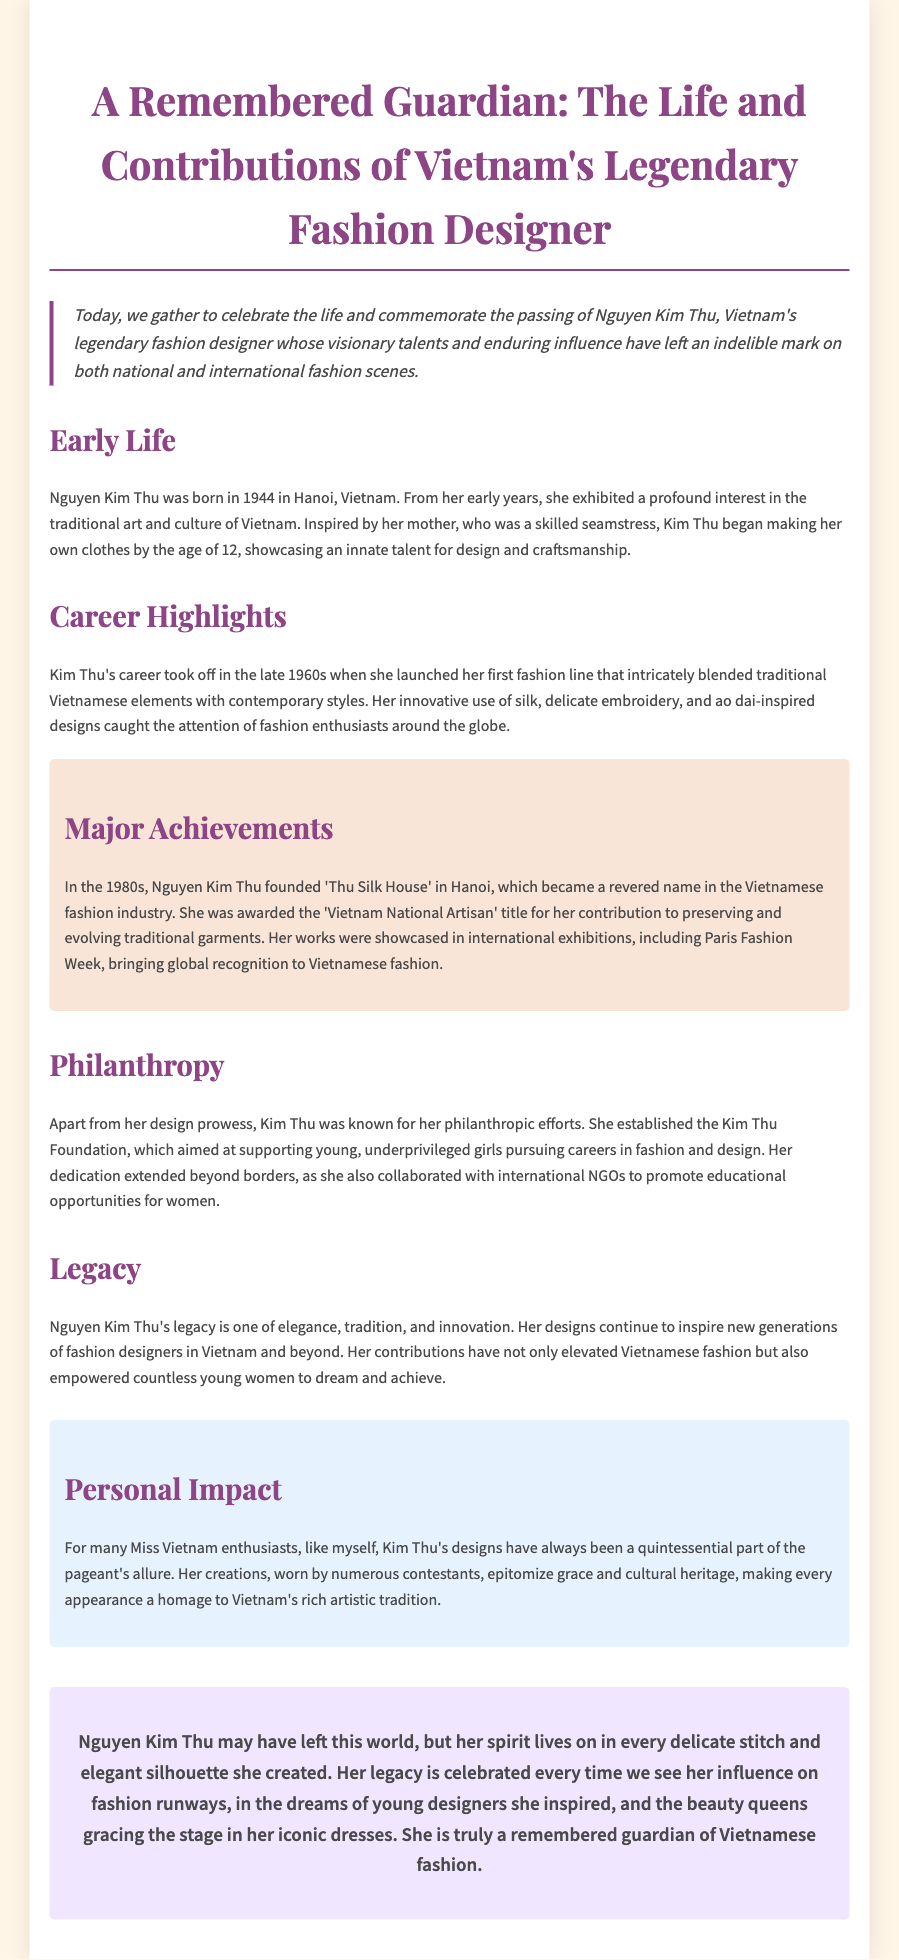What year was Nguyen Kim Thu born? The document states that she was born in 1944.
Answer: 1944 What was the name of Kim Thu's fashion house? The document mentions that she founded 'Thu Silk House' in Hanoi.
Answer: Thu Silk House Which prestigious fashion event featured her works? The document highlights that her works were showcased in Paris Fashion Week.
Answer: Paris Fashion Week What title was Nguyen Kim Thu awarded? The document states that she was awarded the 'Vietnam National Artisan' title.
Answer: Vietnam National Artisan What did the Kim Thu Foundation support? The document states that the foundation aimed at supporting young, underprivileged girls pursuing careers in fashion and design.
Answer: Young, underprivileged girls How did Nguyen Kim Thu influence Miss Vietnam pageants? The document mentions that her designs epitomize grace and cultural heritage for contestants.
Answer: Grace and cultural heritage What does Kim Thu's legacy represent? It is stated in the document that her legacy is one of elegance, tradition, and innovation.
Answer: Elegance, tradition, and innovation In what way did she contribute to empowering young women? The document describes her dedication to promoting educational opportunities for women.
Answer: Promoting educational opportunities What is the overall tone of the eulogy? The document conveys a tone of admiration and remembrance for Nguyen Kim Thu's contributions.
Answer: Admiration and remembrance 